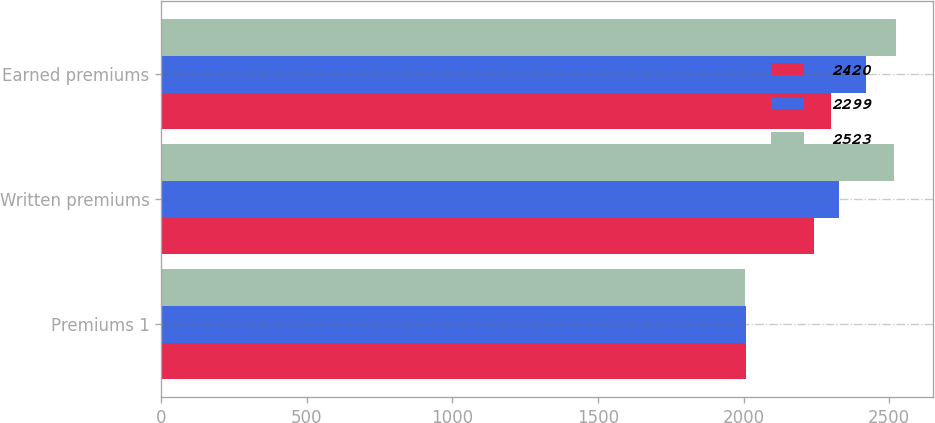Convert chart. <chart><loc_0><loc_0><loc_500><loc_500><stacked_bar_chart><ecel><fcel>Premiums 1<fcel>Written premiums<fcel>Earned premiums<nl><fcel>2420<fcel>2008<fcel>2242<fcel>2299<nl><fcel>2299<fcel>2007<fcel>2326<fcel>2420<nl><fcel>2523<fcel>2006<fcel>2515<fcel>2523<nl></chart> 